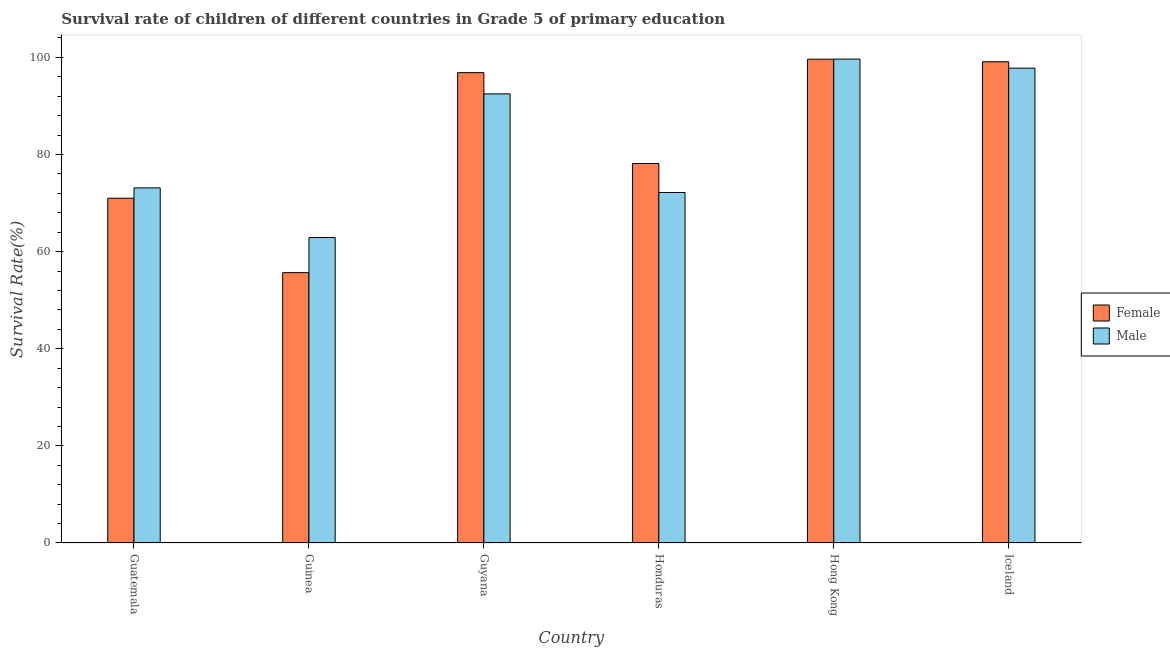How many different coloured bars are there?
Keep it short and to the point. 2. What is the label of the 5th group of bars from the left?
Give a very brief answer. Hong Kong. What is the survival rate of female students in primary education in Honduras?
Ensure brevity in your answer.  78.15. Across all countries, what is the maximum survival rate of female students in primary education?
Offer a terse response. 99.63. Across all countries, what is the minimum survival rate of female students in primary education?
Your response must be concise. 55.67. In which country was the survival rate of male students in primary education maximum?
Offer a terse response. Hong Kong. In which country was the survival rate of male students in primary education minimum?
Ensure brevity in your answer.  Guinea. What is the total survival rate of female students in primary education in the graph?
Keep it short and to the point. 500.41. What is the difference between the survival rate of male students in primary education in Guatemala and that in Honduras?
Give a very brief answer. 0.95. What is the difference between the survival rate of female students in primary education in Guyana and the survival rate of male students in primary education in Guatemala?
Your answer should be compact. 23.73. What is the average survival rate of female students in primary education per country?
Offer a terse response. 83.4. What is the difference between the survival rate of female students in primary education and survival rate of male students in primary education in Guyana?
Provide a succinct answer. 4.37. What is the ratio of the survival rate of male students in primary education in Guatemala to that in Hong Kong?
Ensure brevity in your answer.  0.73. Is the difference between the survival rate of male students in primary education in Guatemala and Iceland greater than the difference between the survival rate of female students in primary education in Guatemala and Iceland?
Your answer should be compact. Yes. What is the difference between the highest and the second highest survival rate of female students in primary education?
Your answer should be very brief. 0.52. What is the difference between the highest and the lowest survival rate of female students in primary education?
Ensure brevity in your answer.  43.96. In how many countries, is the survival rate of male students in primary education greater than the average survival rate of male students in primary education taken over all countries?
Provide a succinct answer. 3. Is the sum of the survival rate of female students in primary education in Guatemala and Hong Kong greater than the maximum survival rate of male students in primary education across all countries?
Provide a short and direct response. Yes. What does the 1st bar from the left in Guatemala represents?
Ensure brevity in your answer.  Female. Are the values on the major ticks of Y-axis written in scientific E-notation?
Provide a short and direct response. No. Does the graph contain any zero values?
Your response must be concise. No. What is the title of the graph?
Your answer should be compact. Survival rate of children of different countries in Grade 5 of primary education. What is the label or title of the Y-axis?
Keep it short and to the point. Survival Rate(%). What is the Survival Rate(%) of Female in Guatemala?
Offer a terse response. 71. What is the Survival Rate(%) of Male in Guatemala?
Offer a very short reply. 73.13. What is the Survival Rate(%) of Female in Guinea?
Ensure brevity in your answer.  55.67. What is the Survival Rate(%) in Male in Guinea?
Provide a short and direct response. 62.9. What is the Survival Rate(%) of Female in Guyana?
Your response must be concise. 96.85. What is the Survival Rate(%) of Male in Guyana?
Provide a short and direct response. 92.49. What is the Survival Rate(%) of Female in Honduras?
Provide a short and direct response. 78.15. What is the Survival Rate(%) of Male in Honduras?
Give a very brief answer. 72.17. What is the Survival Rate(%) in Female in Hong Kong?
Keep it short and to the point. 99.63. What is the Survival Rate(%) of Male in Hong Kong?
Make the answer very short. 99.65. What is the Survival Rate(%) of Female in Iceland?
Your response must be concise. 99.11. What is the Survival Rate(%) in Male in Iceland?
Your answer should be very brief. 97.78. Across all countries, what is the maximum Survival Rate(%) in Female?
Provide a succinct answer. 99.63. Across all countries, what is the maximum Survival Rate(%) of Male?
Ensure brevity in your answer.  99.65. Across all countries, what is the minimum Survival Rate(%) of Female?
Provide a succinct answer. 55.67. Across all countries, what is the minimum Survival Rate(%) of Male?
Offer a very short reply. 62.9. What is the total Survival Rate(%) in Female in the graph?
Make the answer very short. 500.41. What is the total Survival Rate(%) of Male in the graph?
Provide a succinct answer. 498.12. What is the difference between the Survival Rate(%) of Female in Guatemala and that in Guinea?
Provide a succinct answer. 15.32. What is the difference between the Survival Rate(%) in Male in Guatemala and that in Guinea?
Provide a succinct answer. 10.22. What is the difference between the Survival Rate(%) in Female in Guatemala and that in Guyana?
Provide a short and direct response. -25.86. What is the difference between the Survival Rate(%) of Male in Guatemala and that in Guyana?
Offer a very short reply. -19.36. What is the difference between the Survival Rate(%) in Female in Guatemala and that in Honduras?
Provide a succinct answer. -7.15. What is the difference between the Survival Rate(%) of Male in Guatemala and that in Honduras?
Your response must be concise. 0.95. What is the difference between the Survival Rate(%) of Female in Guatemala and that in Hong Kong?
Provide a succinct answer. -28.63. What is the difference between the Survival Rate(%) in Male in Guatemala and that in Hong Kong?
Provide a short and direct response. -26.53. What is the difference between the Survival Rate(%) in Female in Guatemala and that in Iceland?
Make the answer very short. -28.11. What is the difference between the Survival Rate(%) of Male in Guatemala and that in Iceland?
Keep it short and to the point. -24.65. What is the difference between the Survival Rate(%) in Female in Guinea and that in Guyana?
Your response must be concise. -41.18. What is the difference between the Survival Rate(%) in Male in Guinea and that in Guyana?
Make the answer very short. -29.58. What is the difference between the Survival Rate(%) of Female in Guinea and that in Honduras?
Give a very brief answer. -22.48. What is the difference between the Survival Rate(%) in Male in Guinea and that in Honduras?
Keep it short and to the point. -9.27. What is the difference between the Survival Rate(%) in Female in Guinea and that in Hong Kong?
Offer a terse response. -43.96. What is the difference between the Survival Rate(%) of Male in Guinea and that in Hong Kong?
Your answer should be very brief. -36.75. What is the difference between the Survival Rate(%) of Female in Guinea and that in Iceland?
Your response must be concise. -43.43. What is the difference between the Survival Rate(%) in Male in Guinea and that in Iceland?
Your answer should be compact. -34.88. What is the difference between the Survival Rate(%) in Female in Guyana and that in Honduras?
Make the answer very short. 18.71. What is the difference between the Survival Rate(%) of Male in Guyana and that in Honduras?
Provide a succinct answer. 20.31. What is the difference between the Survival Rate(%) in Female in Guyana and that in Hong Kong?
Your response must be concise. -2.78. What is the difference between the Survival Rate(%) of Male in Guyana and that in Hong Kong?
Offer a terse response. -7.17. What is the difference between the Survival Rate(%) of Female in Guyana and that in Iceland?
Provide a succinct answer. -2.25. What is the difference between the Survival Rate(%) in Male in Guyana and that in Iceland?
Keep it short and to the point. -5.3. What is the difference between the Survival Rate(%) of Female in Honduras and that in Hong Kong?
Make the answer very short. -21.48. What is the difference between the Survival Rate(%) of Male in Honduras and that in Hong Kong?
Offer a terse response. -27.48. What is the difference between the Survival Rate(%) of Female in Honduras and that in Iceland?
Offer a terse response. -20.96. What is the difference between the Survival Rate(%) of Male in Honduras and that in Iceland?
Give a very brief answer. -25.61. What is the difference between the Survival Rate(%) in Female in Hong Kong and that in Iceland?
Keep it short and to the point. 0.52. What is the difference between the Survival Rate(%) of Male in Hong Kong and that in Iceland?
Offer a very short reply. 1.87. What is the difference between the Survival Rate(%) of Female in Guatemala and the Survival Rate(%) of Male in Guinea?
Keep it short and to the point. 8.09. What is the difference between the Survival Rate(%) of Female in Guatemala and the Survival Rate(%) of Male in Guyana?
Give a very brief answer. -21.49. What is the difference between the Survival Rate(%) in Female in Guatemala and the Survival Rate(%) in Male in Honduras?
Ensure brevity in your answer.  -1.18. What is the difference between the Survival Rate(%) of Female in Guatemala and the Survival Rate(%) of Male in Hong Kong?
Give a very brief answer. -28.66. What is the difference between the Survival Rate(%) of Female in Guatemala and the Survival Rate(%) of Male in Iceland?
Provide a short and direct response. -26.78. What is the difference between the Survival Rate(%) of Female in Guinea and the Survival Rate(%) of Male in Guyana?
Ensure brevity in your answer.  -36.81. What is the difference between the Survival Rate(%) in Female in Guinea and the Survival Rate(%) in Male in Honduras?
Give a very brief answer. -16.5. What is the difference between the Survival Rate(%) in Female in Guinea and the Survival Rate(%) in Male in Hong Kong?
Give a very brief answer. -43.98. What is the difference between the Survival Rate(%) of Female in Guinea and the Survival Rate(%) of Male in Iceland?
Offer a very short reply. -42.11. What is the difference between the Survival Rate(%) of Female in Guyana and the Survival Rate(%) of Male in Honduras?
Your answer should be compact. 24.68. What is the difference between the Survival Rate(%) of Female in Guyana and the Survival Rate(%) of Male in Hong Kong?
Your response must be concise. -2.8. What is the difference between the Survival Rate(%) in Female in Guyana and the Survival Rate(%) in Male in Iceland?
Give a very brief answer. -0.93. What is the difference between the Survival Rate(%) of Female in Honduras and the Survival Rate(%) of Male in Hong Kong?
Provide a short and direct response. -21.5. What is the difference between the Survival Rate(%) of Female in Honduras and the Survival Rate(%) of Male in Iceland?
Provide a succinct answer. -19.63. What is the difference between the Survival Rate(%) in Female in Hong Kong and the Survival Rate(%) in Male in Iceland?
Give a very brief answer. 1.85. What is the average Survival Rate(%) in Female per country?
Your response must be concise. 83.4. What is the average Survival Rate(%) of Male per country?
Keep it short and to the point. 83.02. What is the difference between the Survival Rate(%) of Female and Survival Rate(%) of Male in Guatemala?
Give a very brief answer. -2.13. What is the difference between the Survival Rate(%) in Female and Survival Rate(%) in Male in Guinea?
Provide a short and direct response. -7.23. What is the difference between the Survival Rate(%) in Female and Survival Rate(%) in Male in Guyana?
Ensure brevity in your answer.  4.37. What is the difference between the Survival Rate(%) in Female and Survival Rate(%) in Male in Honduras?
Make the answer very short. 5.98. What is the difference between the Survival Rate(%) of Female and Survival Rate(%) of Male in Hong Kong?
Provide a succinct answer. -0.02. What is the difference between the Survival Rate(%) in Female and Survival Rate(%) in Male in Iceland?
Keep it short and to the point. 1.33. What is the ratio of the Survival Rate(%) of Female in Guatemala to that in Guinea?
Offer a terse response. 1.28. What is the ratio of the Survival Rate(%) in Male in Guatemala to that in Guinea?
Offer a very short reply. 1.16. What is the ratio of the Survival Rate(%) of Female in Guatemala to that in Guyana?
Ensure brevity in your answer.  0.73. What is the ratio of the Survival Rate(%) of Male in Guatemala to that in Guyana?
Your answer should be very brief. 0.79. What is the ratio of the Survival Rate(%) of Female in Guatemala to that in Honduras?
Ensure brevity in your answer.  0.91. What is the ratio of the Survival Rate(%) in Male in Guatemala to that in Honduras?
Provide a succinct answer. 1.01. What is the ratio of the Survival Rate(%) of Female in Guatemala to that in Hong Kong?
Keep it short and to the point. 0.71. What is the ratio of the Survival Rate(%) in Male in Guatemala to that in Hong Kong?
Your answer should be compact. 0.73. What is the ratio of the Survival Rate(%) of Female in Guatemala to that in Iceland?
Provide a succinct answer. 0.72. What is the ratio of the Survival Rate(%) in Male in Guatemala to that in Iceland?
Ensure brevity in your answer.  0.75. What is the ratio of the Survival Rate(%) of Female in Guinea to that in Guyana?
Offer a terse response. 0.57. What is the ratio of the Survival Rate(%) in Male in Guinea to that in Guyana?
Your answer should be very brief. 0.68. What is the ratio of the Survival Rate(%) in Female in Guinea to that in Honduras?
Ensure brevity in your answer.  0.71. What is the ratio of the Survival Rate(%) of Male in Guinea to that in Honduras?
Keep it short and to the point. 0.87. What is the ratio of the Survival Rate(%) of Female in Guinea to that in Hong Kong?
Your response must be concise. 0.56. What is the ratio of the Survival Rate(%) in Male in Guinea to that in Hong Kong?
Offer a very short reply. 0.63. What is the ratio of the Survival Rate(%) of Female in Guinea to that in Iceland?
Provide a succinct answer. 0.56. What is the ratio of the Survival Rate(%) in Male in Guinea to that in Iceland?
Offer a terse response. 0.64. What is the ratio of the Survival Rate(%) of Female in Guyana to that in Honduras?
Give a very brief answer. 1.24. What is the ratio of the Survival Rate(%) in Male in Guyana to that in Honduras?
Keep it short and to the point. 1.28. What is the ratio of the Survival Rate(%) in Female in Guyana to that in Hong Kong?
Your answer should be compact. 0.97. What is the ratio of the Survival Rate(%) in Male in Guyana to that in Hong Kong?
Ensure brevity in your answer.  0.93. What is the ratio of the Survival Rate(%) of Female in Guyana to that in Iceland?
Your answer should be compact. 0.98. What is the ratio of the Survival Rate(%) of Male in Guyana to that in Iceland?
Your answer should be compact. 0.95. What is the ratio of the Survival Rate(%) in Female in Honduras to that in Hong Kong?
Give a very brief answer. 0.78. What is the ratio of the Survival Rate(%) of Male in Honduras to that in Hong Kong?
Offer a very short reply. 0.72. What is the ratio of the Survival Rate(%) in Female in Honduras to that in Iceland?
Keep it short and to the point. 0.79. What is the ratio of the Survival Rate(%) of Male in Honduras to that in Iceland?
Provide a short and direct response. 0.74. What is the ratio of the Survival Rate(%) of Female in Hong Kong to that in Iceland?
Your answer should be very brief. 1.01. What is the ratio of the Survival Rate(%) in Male in Hong Kong to that in Iceland?
Give a very brief answer. 1.02. What is the difference between the highest and the second highest Survival Rate(%) in Female?
Keep it short and to the point. 0.52. What is the difference between the highest and the second highest Survival Rate(%) of Male?
Ensure brevity in your answer.  1.87. What is the difference between the highest and the lowest Survival Rate(%) of Female?
Make the answer very short. 43.96. What is the difference between the highest and the lowest Survival Rate(%) in Male?
Keep it short and to the point. 36.75. 